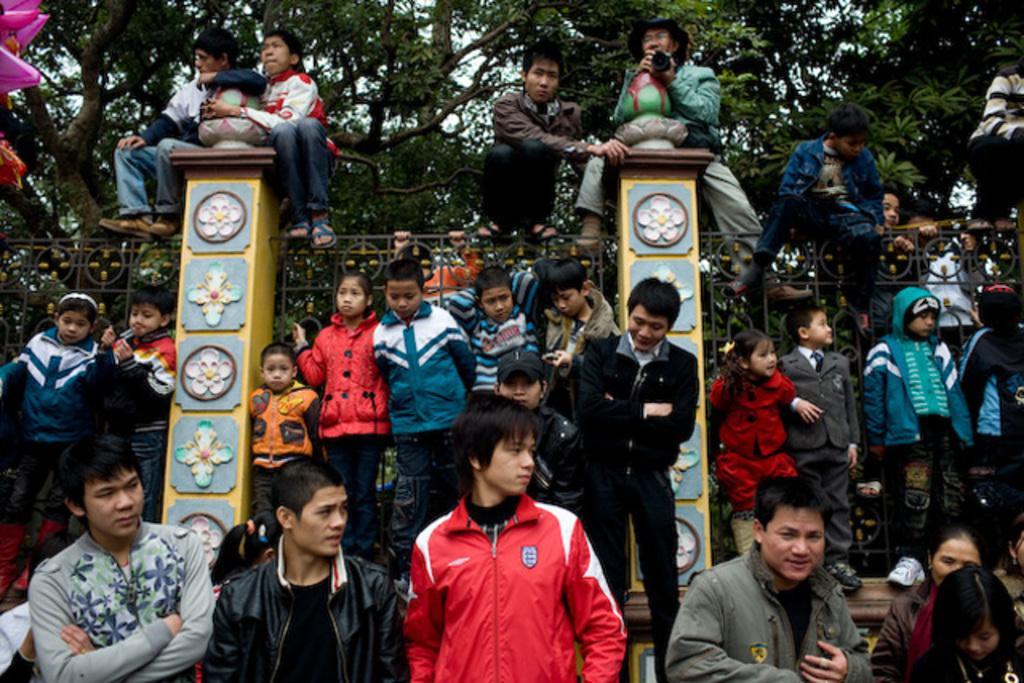Please provide a concise description of this image. In this picture I see few people are standing and few are seated and few are seated on the poles and few are holding metal fence and I see trees. 